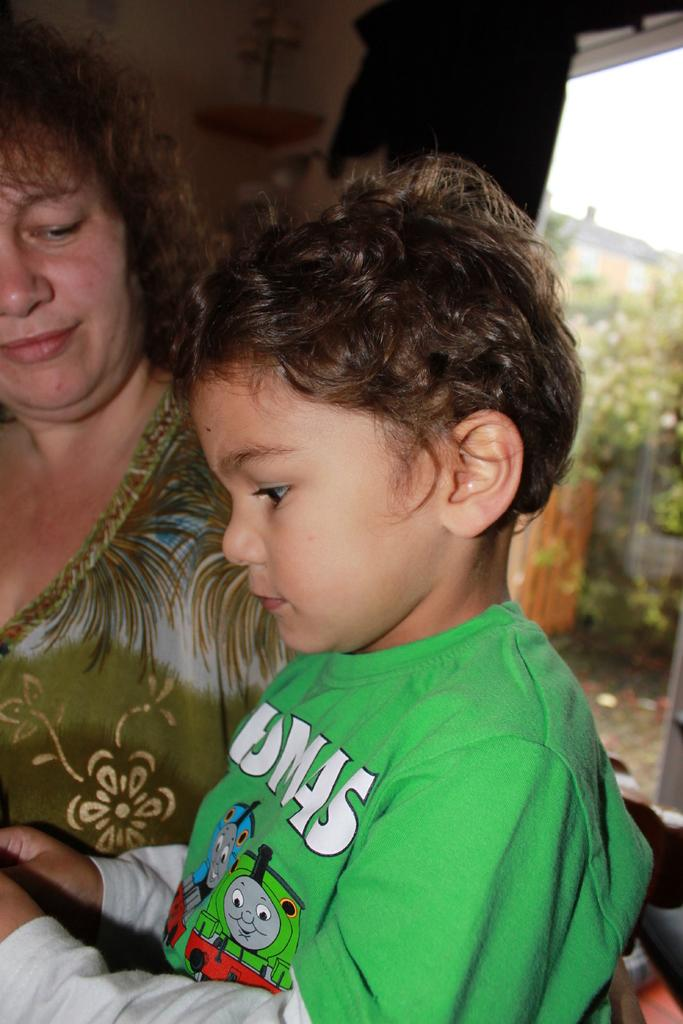Who is present in the image? There is a boy and a woman in the picture. What is the woman doing in the image? The woman is looking at the boy. What can be seen in the background of the picture? There is a window in the background of the picture, and trees are visible behind the window. What type of gun is the boy holding in the image? There is no gun present in the image; the boy is not holding any object. How is the distribution of the trees visible behind the window in the image? The trees are visible behind the window, but there is no information about their distribution in the image. 